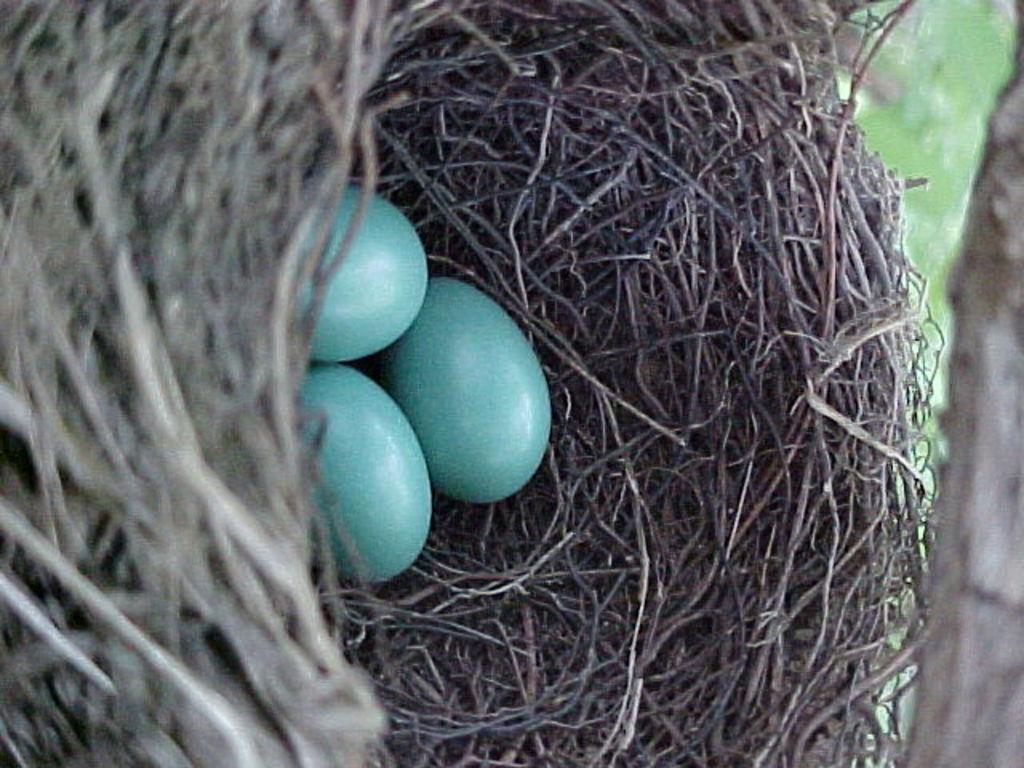Could you give a brief overview of what you see in this image? In this image I can see a nest and in it I can see three eggs. 